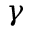Convert formula to latex. <formula><loc_0><loc_0><loc_500><loc_500>\gamma</formula> 